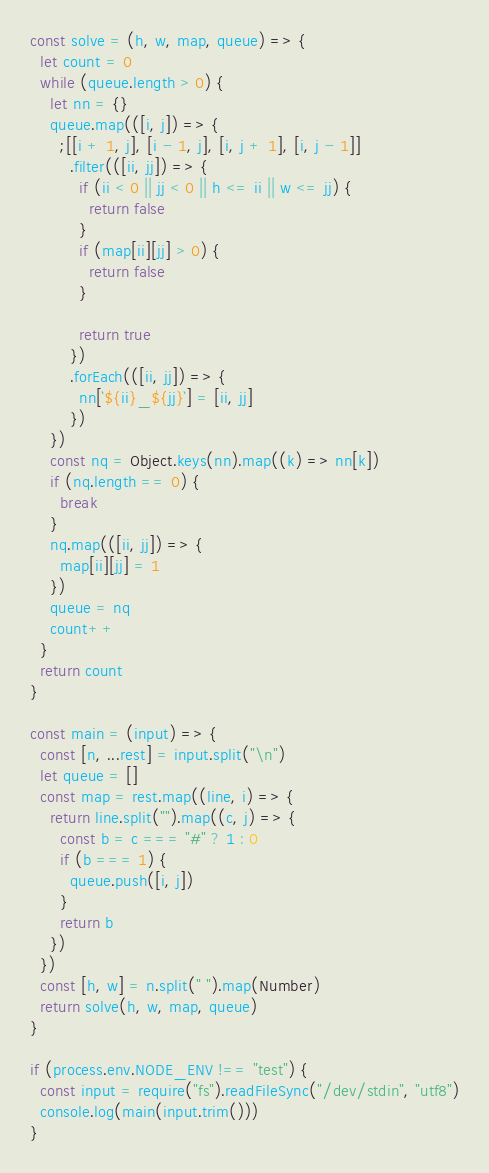Convert code to text. <code><loc_0><loc_0><loc_500><loc_500><_TypeScript_>const solve = (h, w, map, queue) => {
  let count = 0
  while (queue.length > 0) {
    let nn = {}
    queue.map(([i, j]) => {
      ;[[i + 1, j], [i - 1, j], [i, j + 1], [i, j - 1]]
        .filter(([ii, jj]) => {
          if (ii < 0 || jj < 0 || h <= ii || w <= jj) {
            return false
          }
          if (map[ii][jj] > 0) {
            return false
          }

          return true
        })
        .forEach(([ii, jj]) => {
          nn[`${ii}_${jj}`] = [ii, jj]
        })
    })
    const nq = Object.keys(nn).map((k) => nn[k])
    if (nq.length == 0) {
      break
    }
    nq.map(([ii, jj]) => {
      map[ii][jj] = 1
    })
    queue = nq
    count++
  }
  return count
}

const main = (input) => {
  const [n, ...rest] = input.split("\n")
  let queue = []
  const map = rest.map((line, i) => {
    return line.split("").map((c, j) => {
      const b = c === "#" ? 1 : 0
      if (b === 1) {
        queue.push([i, j])
      }
      return b
    })
  })
  const [h, w] = n.split(" ").map(Number)
  return solve(h, w, map, queue)
}

if (process.env.NODE_ENV !== "test") {
  const input = require("fs").readFileSync("/dev/stdin", "utf8")
  console.log(main(input.trim()))
}</code> 